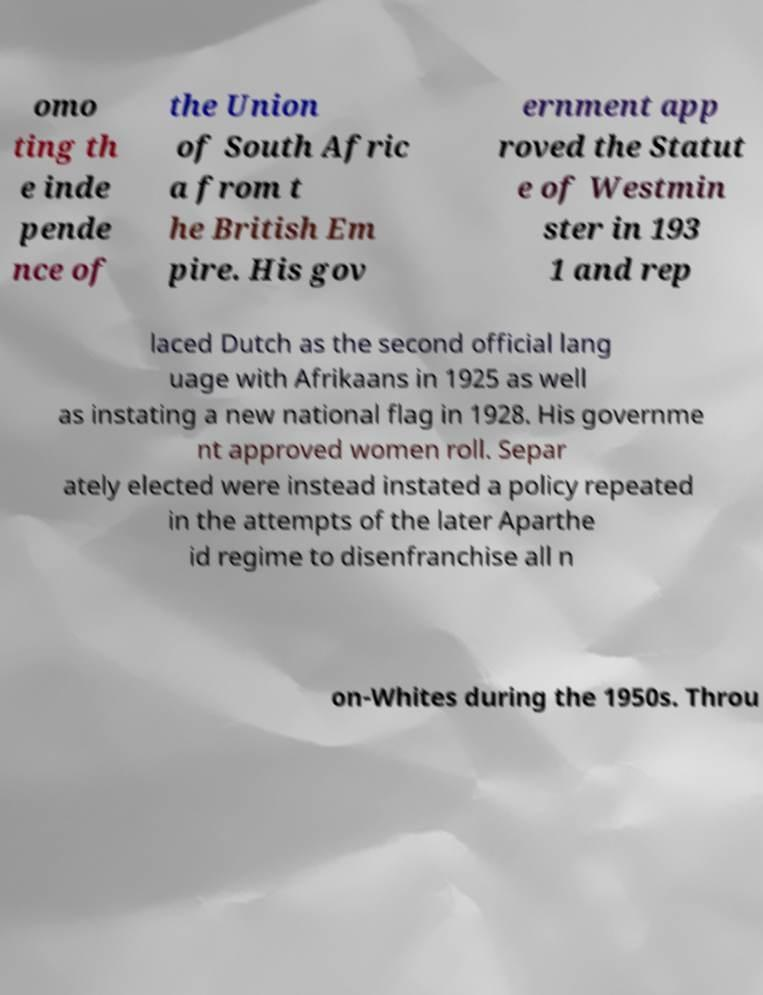Could you extract and type out the text from this image? omo ting th e inde pende nce of the Union of South Afric a from t he British Em pire. His gov ernment app roved the Statut e of Westmin ster in 193 1 and rep laced Dutch as the second official lang uage with Afrikaans in 1925 as well as instating a new national flag in 1928. His governme nt approved women roll. Separ ately elected were instead instated a policy repeated in the attempts of the later Aparthe id regime to disenfranchise all n on-Whites during the 1950s. Throu 